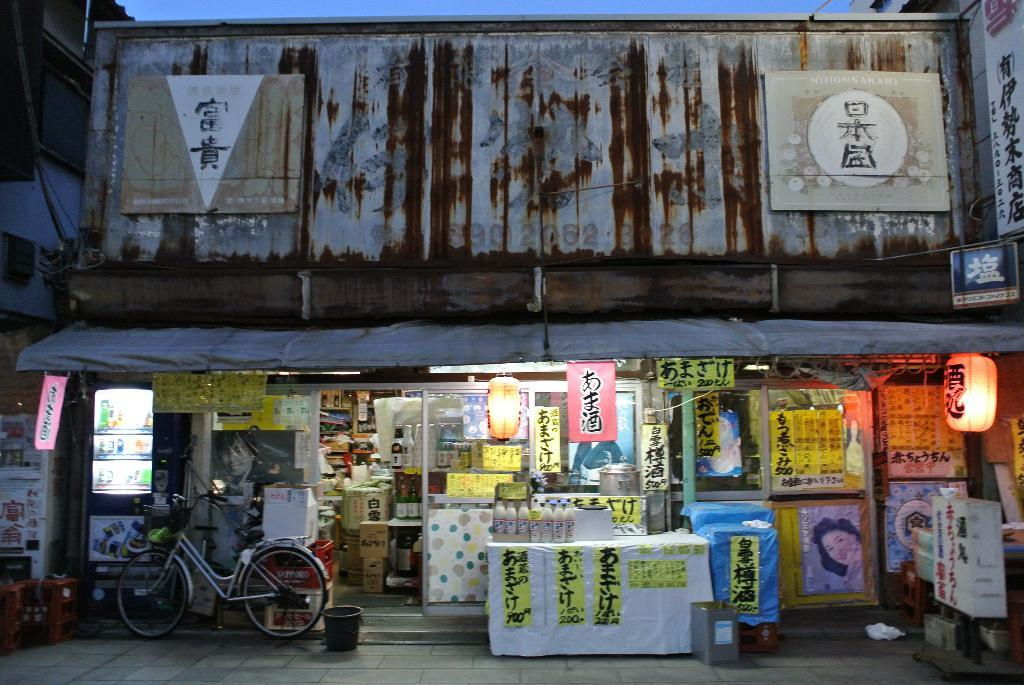<image>
Summarize the visual content of the image. a bike next to a shop with Japanese writing 